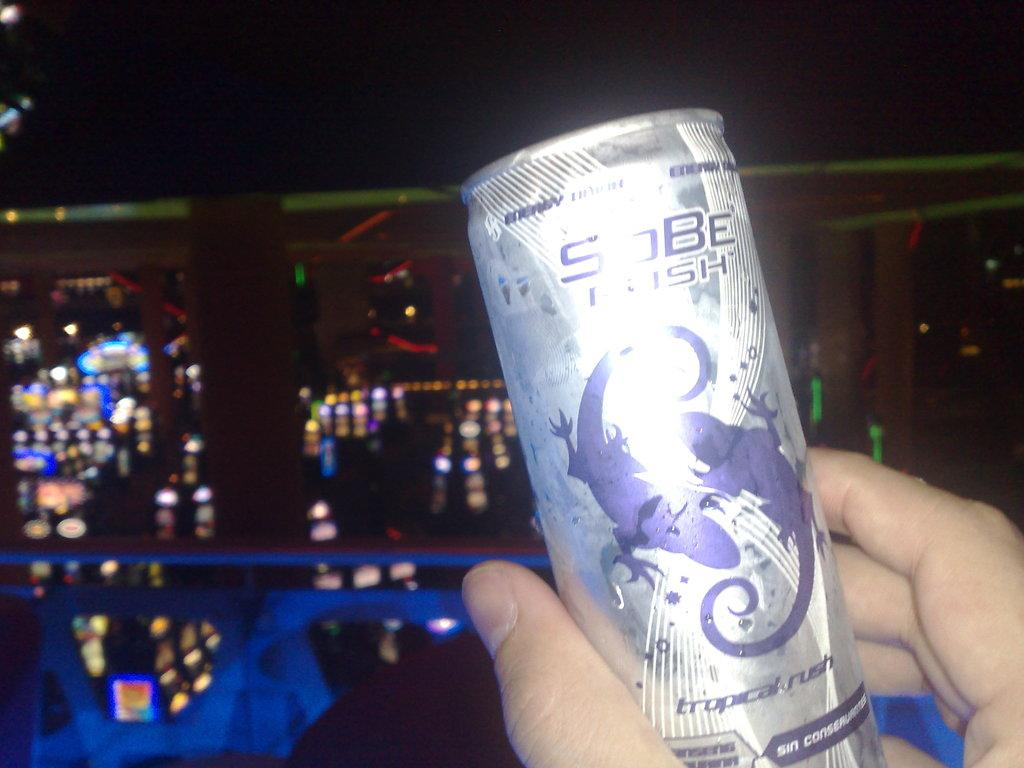<image>
Create a compact narrative representing the image presented. a can that has the word Sobe on it 